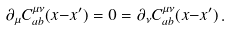<formula> <loc_0><loc_0><loc_500><loc_500>\partial _ { \mu } C _ { a b } ^ { \mu \nu } ( x { - } x ^ { \prime } ) = 0 = \partial _ { \nu } C _ { a b } ^ { \mu \nu } ( x { - } x ^ { \prime } ) \, .</formula> 